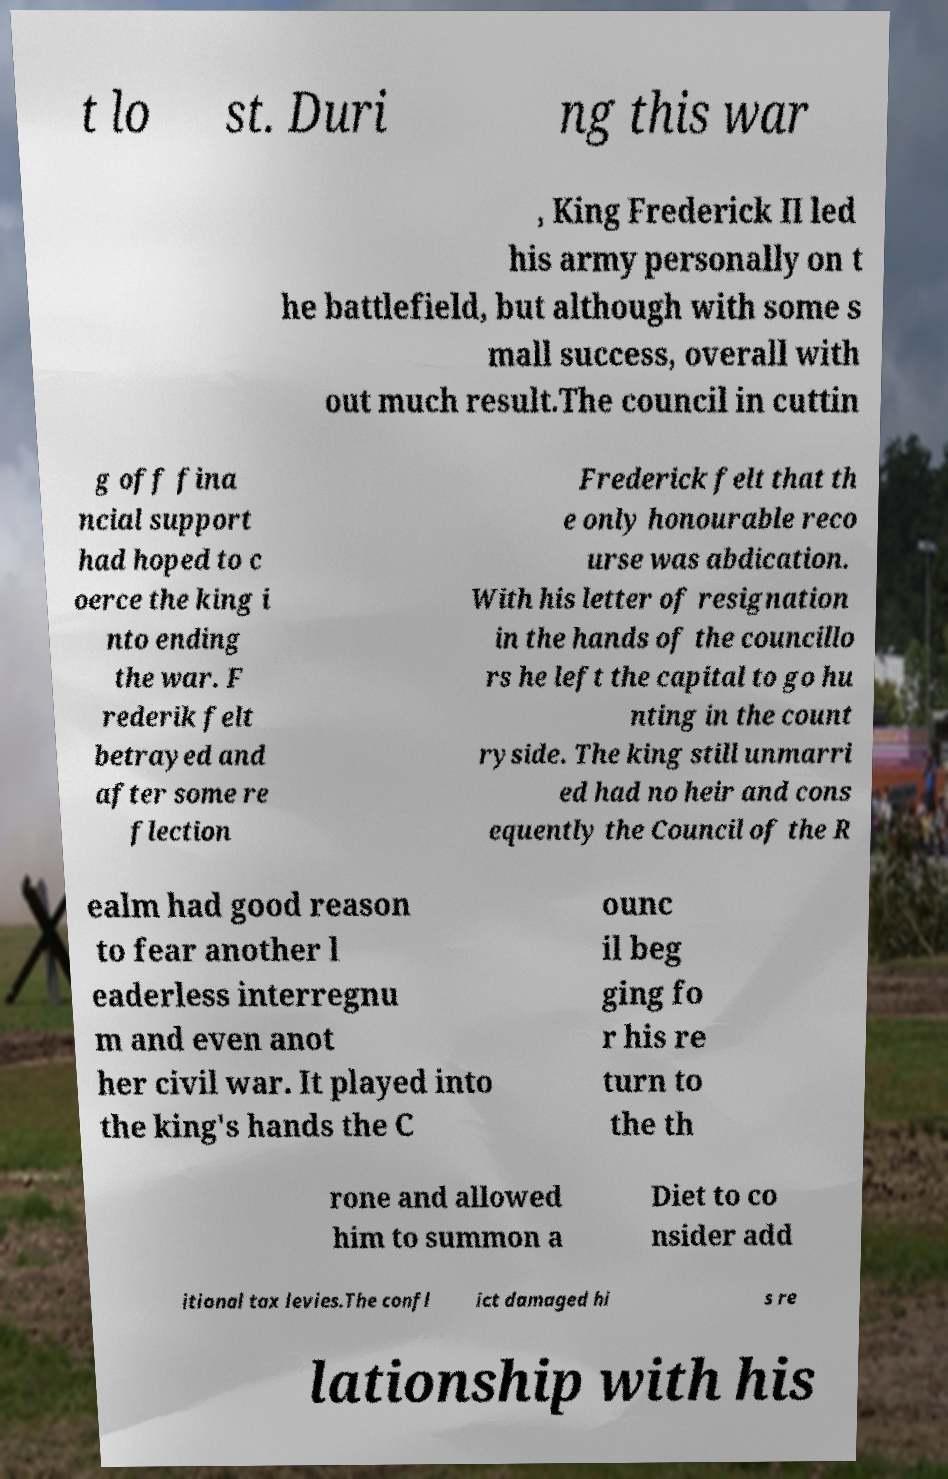Can you read and provide the text displayed in the image?This photo seems to have some interesting text. Can you extract and type it out for me? t lo st. Duri ng this war , King Frederick II led his army personally on t he battlefield, but although with some s mall success, overall with out much result.The council in cuttin g off fina ncial support had hoped to c oerce the king i nto ending the war. F rederik felt betrayed and after some re flection Frederick felt that th e only honourable reco urse was abdication. With his letter of resignation in the hands of the councillo rs he left the capital to go hu nting in the count ryside. The king still unmarri ed had no heir and cons equently the Council of the R ealm had good reason to fear another l eaderless interregnu m and even anot her civil war. It played into the king's hands the C ounc il beg ging fo r his re turn to the th rone and allowed him to summon a Diet to co nsider add itional tax levies.The confl ict damaged hi s re lationship with his 